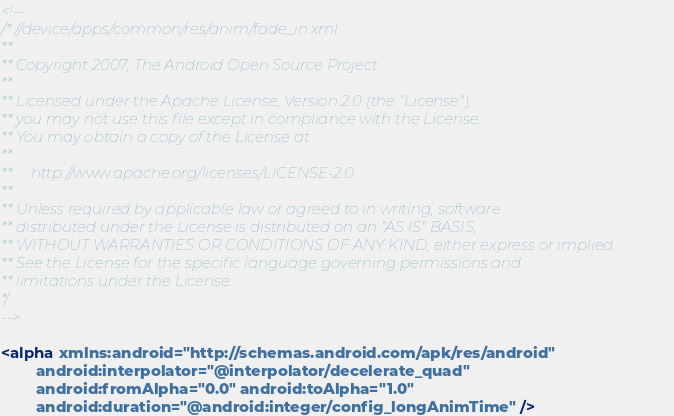Convert code to text. <code><loc_0><loc_0><loc_500><loc_500><_XML_><!--
/* //device/apps/common/res/anim/fade_in.xml
**
** Copyright 2007, The Android Open Source Project
**
** Licensed under the Apache License, Version 2.0 (the "License"); 
** you may not use this file except in compliance with the License. 
** You may obtain a copy of the License at 
**
**     http://www.apache.org/licenses/LICENSE-2.0 
**
** Unless required by applicable law or agreed to in writing, software 
** distributed under the License is distributed on an "AS IS" BASIS, 
** WITHOUT WARRANTIES OR CONDITIONS OF ANY KIND, either express or implied. 
** See the License for the specific language governing permissions and 
** limitations under the License.
*/
-->

<alpha xmlns:android="http://schemas.android.com/apk/res/android"
        android:interpolator="@interpolator/decelerate_quad"
        android:fromAlpha="0.0" android:toAlpha="1.0"
        android:duration="@android:integer/config_longAnimTime" />
</code> 